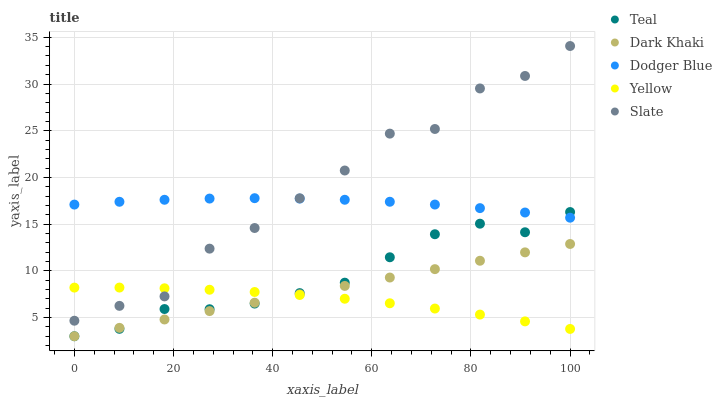Does Yellow have the minimum area under the curve?
Answer yes or no. Yes. Does Slate have the maximum area under the curve?
Answer yes or no. Yes. Does Dodger Blue have the minimum area under the curve?
Answer yes or no. No. Does Dodger Blue have the maximum area under the curve?
Answer yes or no. No. Is Dark Khaki the smoothest?
Answer yes or no. Yes. Is Slate the roughest?
Answer yes or no. Yes. Is Dodger Blue the smoothest?
Answer yes or no. No. Is Dodger Blue the roughest?
Answer yes or no. No. Does Dark Khaki have the lowest value?
Answer yes or no. Yes. Does Slate have the lowest value?
Answer yes or no. No. Does Slate have the highest value?
Answer yes or no. Yes. Does Dodger Blue have the highest value?
Answer yes or no. No. Is Teal less than Slate?
Answer yes or no. Yes. Is Dodger Blue greater than Yellow?
Answer yes or no. Yes. Does Teal intersect Yellow?
Answer yes or no. Yes. Is Teal less than Yellow?
Answer yes or no. No. Is Teal greater than Yellow?
Answer yes or no. No. Does Teal intersect Slate?
Answer yes or no. No. 